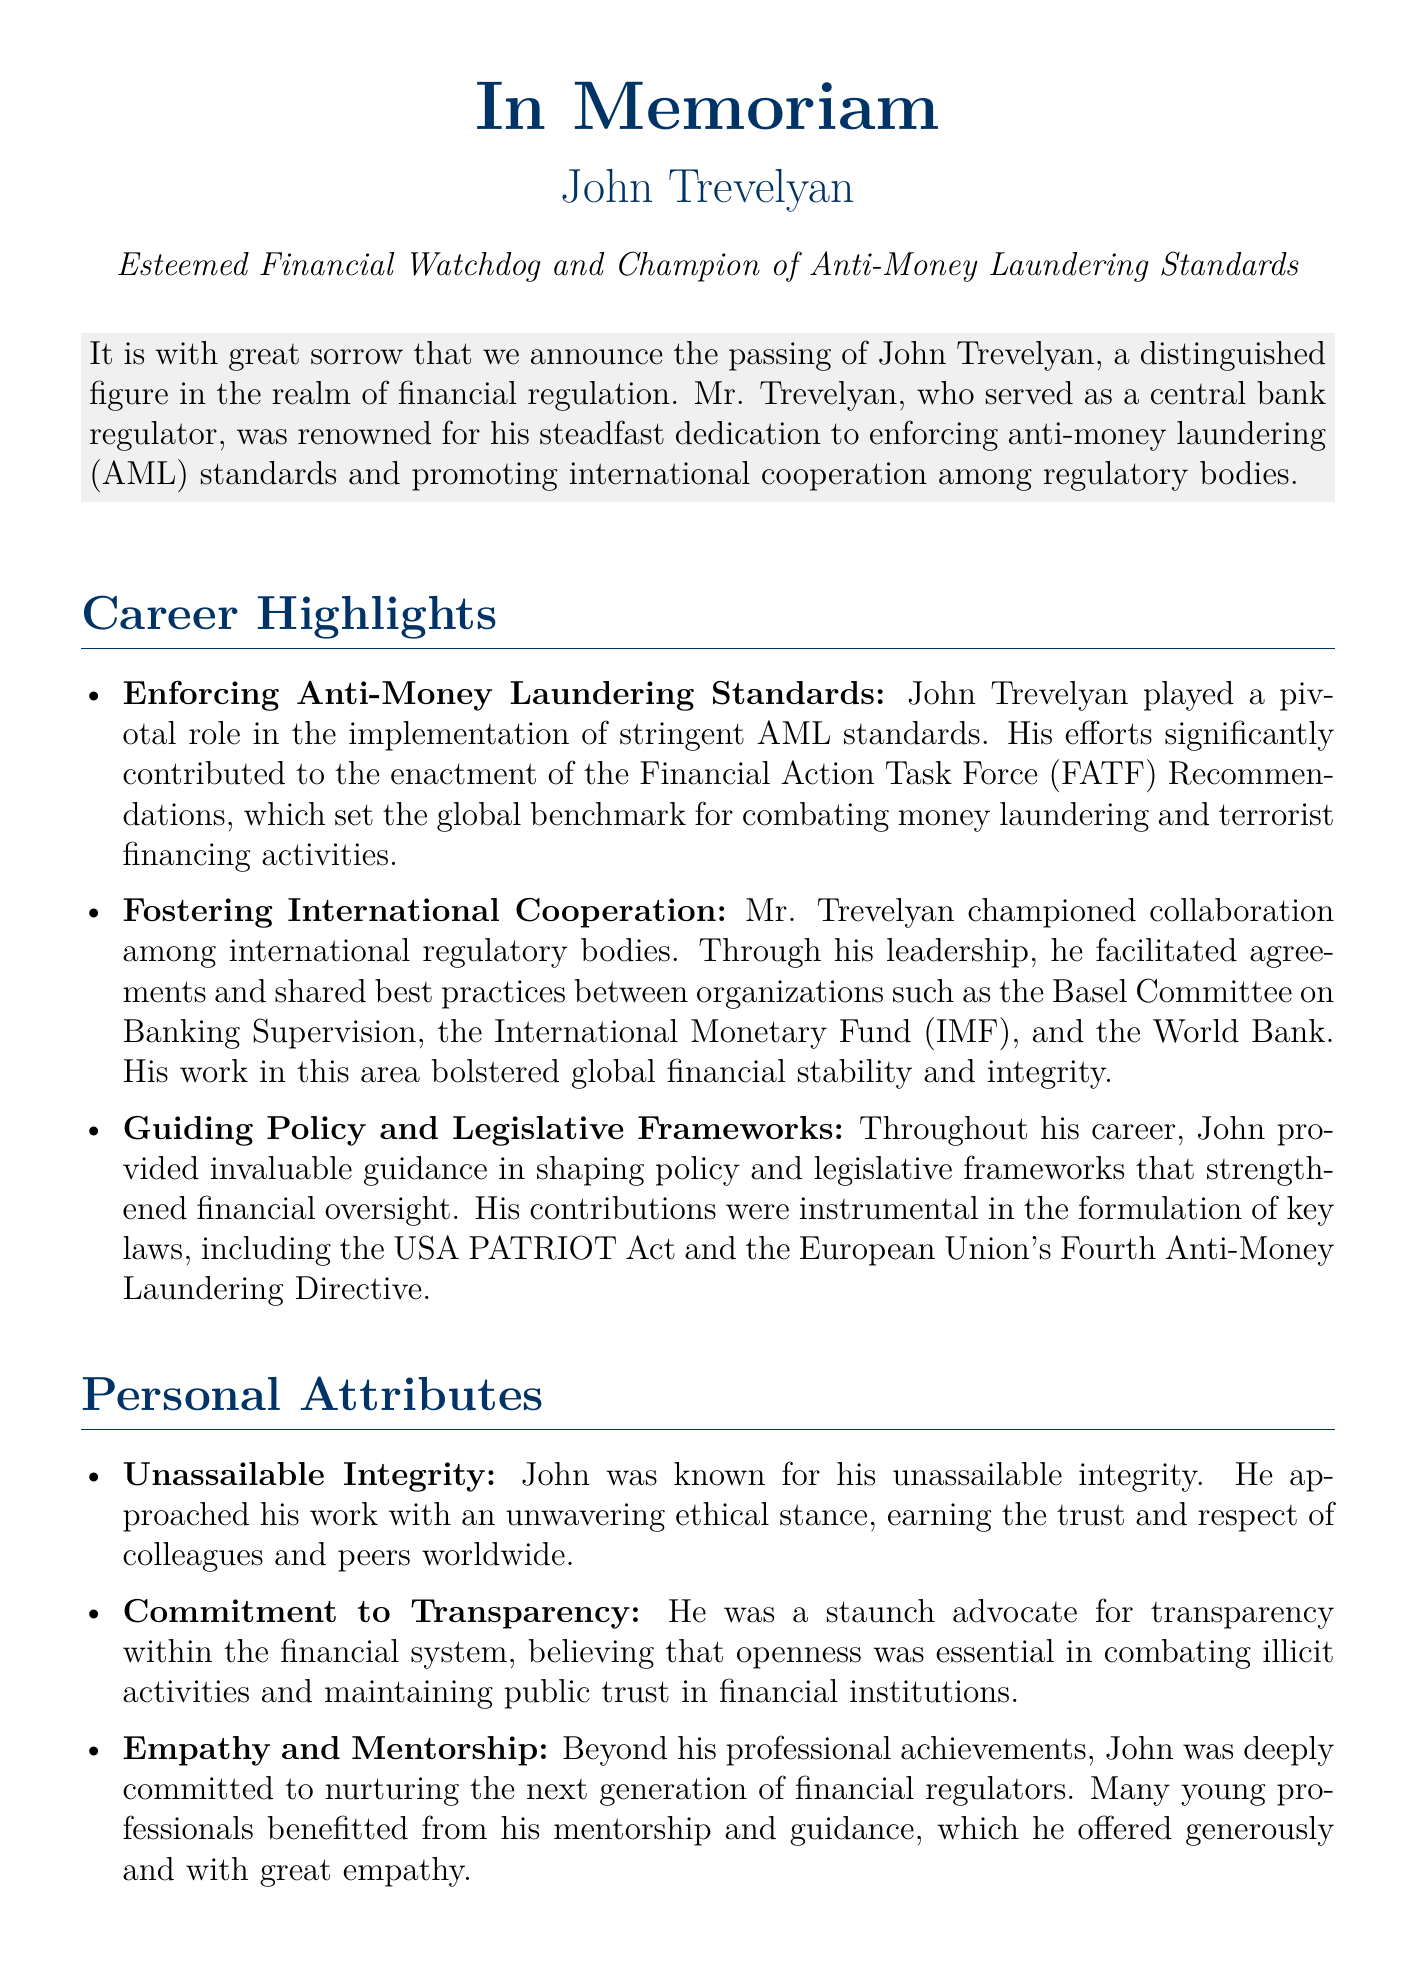What was John Trevelyan known for? John Trevelyan was known for his steadfast dedication to enforcing anti-money laundering standards and promoting international cooperation among regulatory bodies.
Answer: Enforcing anti-money laundering standards What significant role did he play in global financial regulation? He played a pivotal role in the implementation of stringent AML standards and contributed to the enactment of the FATF Recommendations.
Answer: Implementation of stringent AML standards What are the key legislative frameworks John Trevelyan contributed to? He contributed to the formulation of key laws such as the USA PATRIOT Act and the European Union's Fourth Anti-Money Laundering Directive.
Answer: USA PATRIOT Act and the Fourth Anti-Money Laundering Directive What attribute describes his ethical stance? His ethical stance was described as unassailable integrity.
Answer: Unassailable integrity How did John Trevelyan promote transparency? He advocated for transparency within the financial system, believing that openness was essential in combating illicit activities.
Answer: Commitment to transparency Which organizations did he help foster cooperation among? He facilitated cooperation among organizations such as the Basel Committee on Banking Supervision, the IMF, and the World Bank.
Answer: Basel Committee on Banking Supervision, IMF, and World Bank What is highlighted about his approach to mentoring? He was deeply committed to nurturing the next generation of financial regulators through mentorship.
Answer: Nurturing the next generation What legacy did John Trevelyan leave behind? His legacy is characterized by a lifetime dedicated to reinforcing the safeguards of the global financial system.
Answer: Safeguards of the global financial system How many protégés will carry forward his vision? Many protégés will carry forward his vision for a more secure and transparent financial world.
Answer: Many protégés 